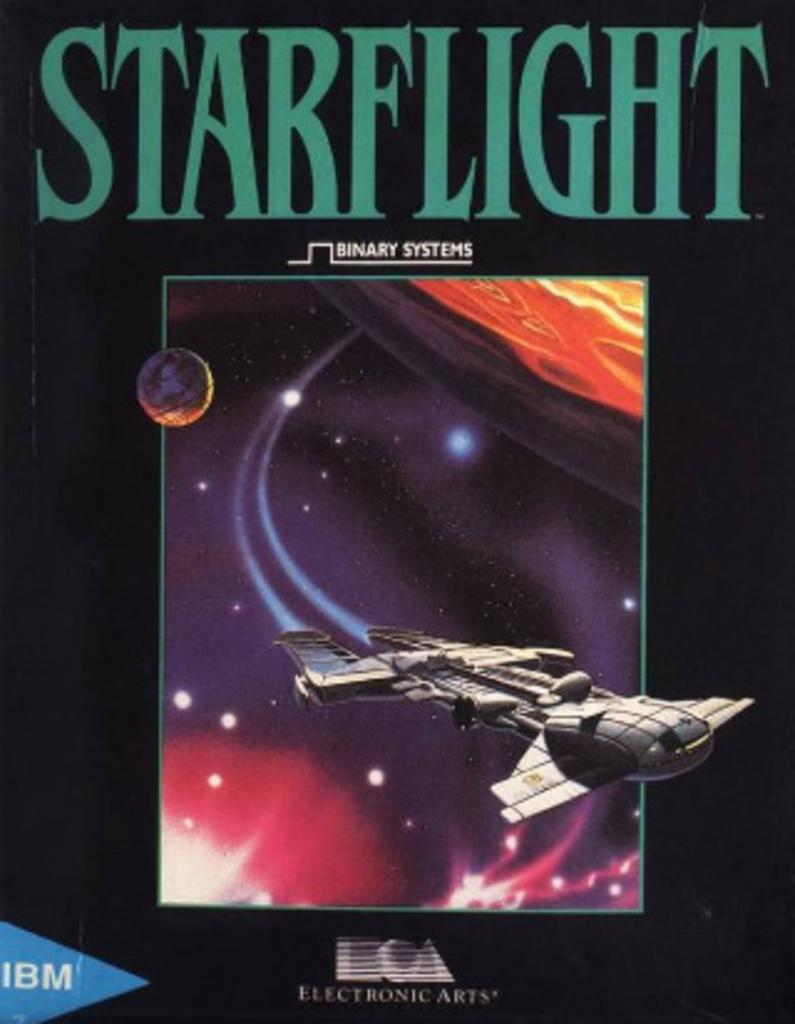<image>
Describe the image concisely. An IBM box with starflight on the front panel. 